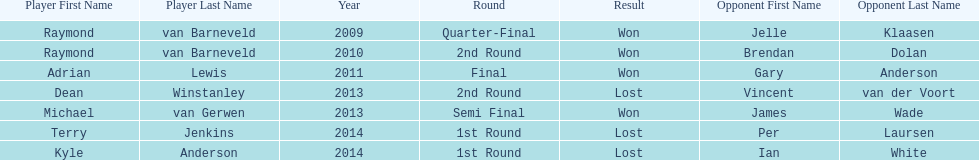Who won the first world darts championship? Raymond van Barneveld. 